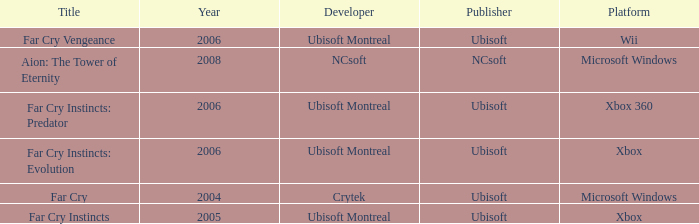Which developer has xbox 360 as the platform? Ubisoft Montreal. 